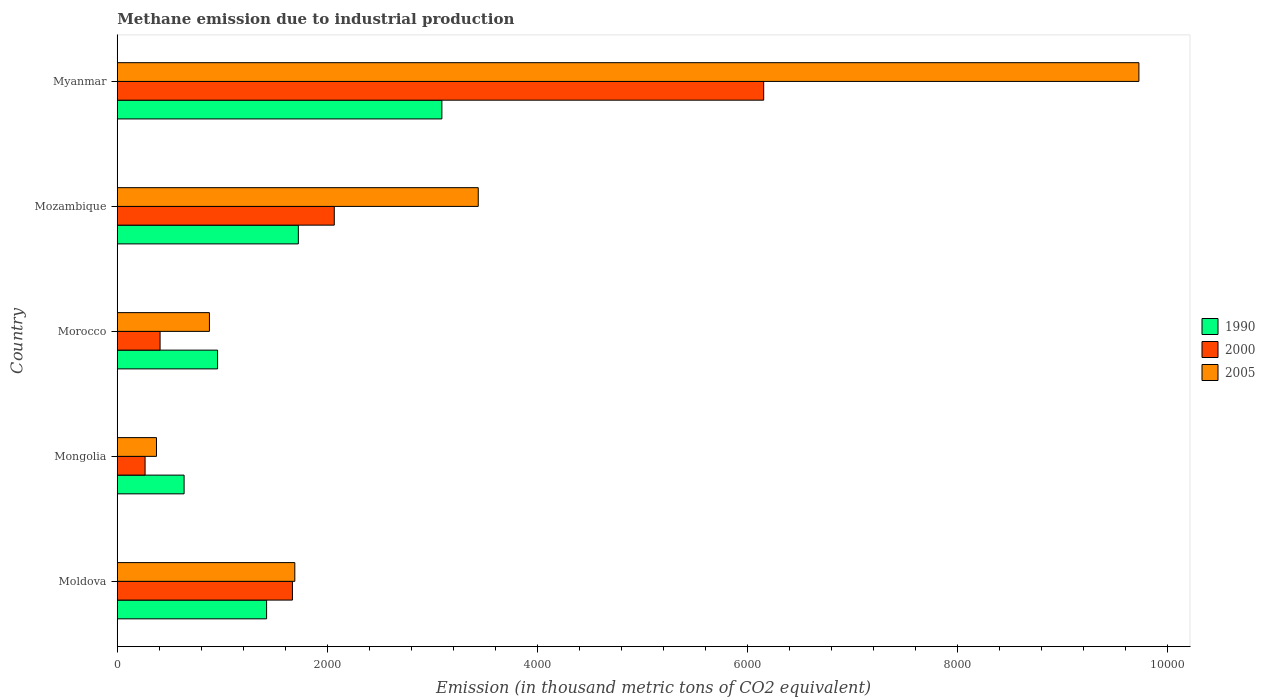How many groups of bars are there?
Provide a succinct answer. 5. Are the number of bars per tick equal to the number of legend labels?
Keep it short and to the point. Yes. Are the number of bars on each tick of the Y-axis equal?
Provide a succinct answer. Yes. How many bars are there on the 2nd tick from the top?
Offer a very short reply. 3. How many bars are there on the 3rd tick from the bottom?
Make the answer very short. 3. What is the label of the 2nd group of bars from the top?
Your answer should be very brief. Mozambique. In how many cases, is the number of bars for a given country not equal to the number of legend labels?
Give a very brief answer. 0. What is the amount of methane emitted in 2005 in Mozambique?
Your answer should be compact. 3438.4. Across all countries, what is the maximum amount of methane emitted in 2000?
Ensure brevity in your answer.  6157.4. Across all countries, what is the minimum amount of methane emitted in 2000?
Your answer should be compact. 264.8. In which country was the amount of methane emitted in 2005 maximum?
Your answer should be compact. Myanmar. In which country was the amount of methane emitted in 1990 minimum?
Make the answer very short. Mongolia. What is the total amount of methane emitted in 2005 in the graph?
Offer a terse response. 1.61e+04. What is the difference between the amount of methane emitted in 1990 in Mongolia and that in Myanmar?
Your response must be concise. -2455.4. What is the difference between the amount of methane emitted in 2000 in Moldova and the amount of methane emitted in 1990 in Myanmar?
Provide a succinct answer. -1423.4. What is the average amount of methane emitted in 2000 per country?
Your answer should be very brief. 2113.08. What is the difference between the amount of methane emitted in 2005 and amount of methane emitted in 2000 in Moldova?
Your response must be concise. 22.6. In how many countries, is the amount of methane emitted in 2005 greater than 2800 thousand metric tons?
Your answer should be very brief. 2. What is the ratio of the amount of methane emitted in 2000 in Morocco to that in Mozambique?
Provide a succinct answer. 0.2. Is the amount of methane emitted in 2000 in Morocco less than that in Myanmar?
Make the answer very short. Yes. Is the difference between the amount of methane emitted in 2005 in Mozambique and Myanmar greater than the difference between the amount of methane emitted in 2000 in Mozambique and Myanmar?
Make the answer very short. No. What is the difference between the highest and the second highest amount of methane emitted in 1990?
Offer a very short reply. 1367.2. What is the difference between the highest and the lowest amount of methane emitted in 2000?
Offer a very short reply. 5892.6. In how many countries, is the amount of methane emitted in 2000 greater than the average amount of methane emitted in 2000 taken over all countries?
Provide a succinct answer. 1. What does the 2nd bar from the top in Mozambique represents?
Offer a very short reply. 2000. Is it the case that in every country, the sum of the amount of methane emitted in 1990 and amount of methane emitted in 2000 is greater than the amount of methane emitted in 2005?
Give a very brief answer. No. How many bars are there?
Keep it short and to the point. 15. Are all the bars in the graph horizontal?
Provide a succinct answer. Yes. How many countries are there in the graph?
Keep it short and to the point. 5. How are the legend labels stacked?
Your response must be concise. Vertical. What is the title of the graph?
Offer a very short reply. Methane emission due to industrial production. Does "2008" appear as one of the legend labels in the graph?
Provide a succinct answer. No. What is the label or title of the X-axis?
Provide a short and direct response. Emission (in thousand metric tons of CO2 equivalent). What is the Emission (in thousand metric tons of CO2 equivalent) of 1990 in Moldova?
Make the answer very short. 1422.3. What is the Emission (in thousand metric tons of CO2 equivalent) of 2000 in Moldova?
Provide a short and direct response. 1668.5. What is the Emission (in thousand metric tons of CO2 equivalent) in 2005 in Moldova?
Offer a very short reply. 1691.1. What is the Emission (in thousand metric tons of CO2 equivalent) in 1990 in Mongolia?
Ensure brevity in your answer.  636.5. What is the Emission (in thousand metric tons of CO2 equivalent) in 2000 in Mongolia?
Ensure brevity in your answer.  264.8. What is the Emission (in thousand metric tons of CO2 equivalent) in 2005 in Mongolia?
Your answer should be compact. 373.5. What is the Emission (in thousand metric tons of CO2 equivalent) of 1990 in Morocco?
Ensure brevity in your answer.  955.4. What is the Emission (in thousand metric tons of CO2 equivalent) of 2000 in Morocco?
Provide a succinct answer. 407.6. What is the Emission (in thousand metric tons of CO2 equivalent) of 2005 in Morocco?
Your answer should be very brief. 877.7. What is the Emission (in thousand metric tons of CO2 equivalent) of 1990 in Mozambique?
Give a very brief answer. 1724.7. What is the Emission (in thousand metric tons of CO2 equivalent) in 2000 in Mozambique?
Provide a succinct answer. 2067.1. What is the Emission (in thousand metric tons of CO2 equivalent) of 2005 in Mozambique?
Offer a very short reply. 3438.4. What is the Emission (in thousand metric tons of CO2 equivalent) in 1990 in Myanmar?
Keep it short and to the point. 3091.9. What is the Emission (in thousand metric tons of CO2 equivalent) in 2000 in Myanmar?
Provide a short and direct response. 6157.4. What is the Emission (in thousand metric tons of CO2 equivalent) in 2005 in Myanmar?
Give a very brief answer. 9731.7. Across all countries, what is the maximum Emission (in thousand metric tons of CO2 equivalent) of 1990?
Keep it short and to the point. 3091.9. Across all countries, what is the maximum Emission (in thousand metric tons of CO2 equivalent) of 2000?
Make the answer very short. 6157.4. Across all countries, what is the maximum Emission (in thousand metric tons of CO2 equivalent) of 2005?
Make the answer very short. 9731.7. Across all countries, what is the minimum Emission (in thousand metric tons of CO2 equivalent) of 1990?
Give a very brief answer. 636.5. Across all countries, what is the minimum Emission (in thousand metric tons of CO2 equivalent) of 2000?
Ensure brevity in your answer.  264.8. Across all countries, what is the minimum Emission (in thousand metric tons of CO2 equivalent) in 2005?
Provide a succinct answer. 373.5. What is the total Emission (in thousand metric tons of CO2 equivalent) in 1990 in the graph?
Give a very brief answer. 7830.8. What is the total Emission (in thousand metric tons of CO2 equivalent) in 2000 in the graph?
Make the answer very short. 1.06e+04. What is the total Emission (in thousand metric tons of CO2 equivalent) in 2005 in the graph?
Offer a very short reply. 1.61e+04. What is the difference between the Emission (in thousand metric tons of CO2 equivalent) in 1990 in Moldova and that in Mongolia?
Provide a short and direct response. 785.8. What is the difference between the Emission (in thousand metric tons of CO2 equivalent) of 2000 in Moldova and that in Mongolia?
Ensure brevity in your answer.  1403.7. What is the difference between the Emission (in thousand metric tons of CO2 equivalent) in 2005 in Moldova and that in Mongolia?
Keep it short and to the point. 1317.6. What is the difference between the Emission (in thousand metric tons of CO2 equivalent) in 1990 in Moldova and that in Morocco?
Your answer should be very brief. 466.9. What is the difference between the Emission (in thousand metric tons of CO2 equivalent) in 2000 in Moldova and that in Morocco?
Keep it short and to the point. 1260.9. What is the difference between the Emission (in thousand metric tons of CO2 equivalent) of 2005 in Moldova and that in Morocco?
Ensure brevity in your answer.  813.4. What is the difference between the Emission (in thousand metric tons of CO2 equivalent) in 1990 in Moldova and that in Mozambique?
Ensure brevity in your answer.  -302.4. What is the difference between the Emission (in thousand metric tons of CO2 equivalent) of 2000 in Moldova and that in Mozambique?
Your answer should be very brief. -398.6. What is the difference between the Emission (in thousand metric tons of CO2 equivalent) in 2005 in Moldova and that in Mozambique?
Provide a short and direct response. -1747.3. What is the difference between the Emission (in thousand metric tons of CO2 equivalent) of 1990 in Moldova and that in Myanmar?
Offer a terse response. -1669.6. What is the difference between the Emission (in thousand metric tons of CO2 equivalent) in 2000 in Moldova and that in Myanmar?
Make the answer very short. -4488.9. What is the difference between the Emission (in thousand metric tons of CO2 equivalent) of 2005 in Moldova and that in Myanmar?
Provide a short and direct response. -8040.6. What is the difference between the Emission (in thousand metric tons of CO2 equivalent) in 1990 in Mongolia and that in Morocco?
Your response must be concise. -318.9. What is the difference between the Emission (in thousand metric tons of CO2 equivalent) of 2000 in Mongolia and that in Morocco?
Your answer should be very brief. -142.8. What is the difference between the Emission (in thousand metric tons of CO2 equivalent) of 2005 in Mongolia and that in Morocco?
Provide a succinct answer. -504.2. What is the difference between the Emission (in thousand metric tons of CO2 equivalent) in 1990 in Mongolia and that in Mozambique?
Your answer should be compact. -1088.2. What is the difference between the Emission (in thousand metric tons of CO2 equivalent) in 2000 in Mongolia and that in Mozambique?
Keep it short and to the point. -1802.3. What is the difference between the Emission (in thousand metric tons of CO2 equivalent) of 2005 in Mongolia and that in Mozambique?
Your response must be concise. -3064.9. What is the difference between the Emission (in thousand metric tons of CO2 equivalent) of 1990 in Mongolia and that in Myanmar?
Make the answer very short. -2455.4. What is the difference between the Emission (in thousand metric tons of CO2 equivalent) of 2000 in Mongolia and that in Myanmar?
Provide a short and direct response. -5892.6. What is the difference between the Emission (in thousand metric tons of CO2 equivalent) of 2005 in Mongolia and that in Myanmar?
Make the answer very short. -9358.2. What is the difference between the Emission (in thousand metric tons of CO2 equivalent) in 1990 in Morocco and that in Mozambique?
Ensure brevity in your answer.  -769.3. What is the difference between the Emission (in thousand metric tons of CO2 equivalent) of 2000 in Morocco and that in Mozambique?
Offer a very short reply. -1659.5. What is the difference between the Emission (in thousand metric tons of CO2 equivalent) in 2005 in Morocco and that in Mozambique?
Make the answer very short. -2560.7. What is the difference between the Emission (in thousand metric tons of CO2 equivalent) in 1990 in Morocco and that in Myanmar?
Offer a terse response. -2136.5. What is the difference between the Emission (in thousand metric tons of CO2 equivalent) in 2000 in Morocco and that in Myanmar?
Keep it short and to the point. -5749.8. What is the difference between the Emission (in thousand metric tons of CO2 equivalent) of 2005 in Morocco and that in Myanmar?
Your answer should be very brief. -8854. What is the difference between the Emission (in thousand metric tons of CO2 equivalent) of 1990 in Mozambique and that in Myanmar?
Offer a very short reply. -1367.2. What is the difference between the Emission (in thousand metric tons of CO2 equivalent) in 2000 in Mozambique and that in Myanmar?
Provide a succinct answer. -4090.3. What is the difference between the Emission (in thousand metric tons of CO2 equivalent) of 2005 in Mozambique and that in Myanmar?
Make the answer very short. -6293.3. What is the difference between the Emission (in thousand metric tons of CO2 equivalent) in 1990 in Moldova and the Emission (in thousand metric tons of CO2 equivalent) in 2000 in Mongolia?
Provide a short and direct response. 1157.5. What is the difference between the Emission (in thousand metric tons of CO2 equivalent) in 1990 in Moldova and the Emission (in thousand metric tons of CO2 equivalent) in 2005 in Mongolia?
Your answer should be compact. 1048.8. What is the difference between the Emission (in thousand metric tons of CO2 equivalent) in 2000 in Moldova and the Emission (in thousand metric tons of CO2 equivalent) in 2005 in Mongolia?
Your response must be concise. 1295. What is the difference between the Emission (in thousand metric tons of CO2 equivalent) in 1990 in Moldova and the Emission (in thousand metric tons of CO2 equivalent) in 2000 in Morocco?
Your answer should be very brief. 1014.7. What is the difference between the Emission (in thousand metric tons of CO2 equivalent) of 1990 in Moldova and the Emission (in thousand metric tons of CO2 equivalent) of 2005 in Morocco?
Your response must be concise. 544.6. What is the difference between the Emission (in thousand metric tons of CO2 equivalent) of 2000 in Moldova and the Emission (in thousand metric tons of CO2 equivalent) of 2005 in Morocco?
Your answer should be very brief. 790.8. What is the difference between the Emission (in thousand metric tons of CO2 equivalent) in 1990 in Moldova and the Emission (in thousand metric tons of CO2 equivalent) in 2000 in Mozambique?
Your answer should be very brief. -644.8. What is the difference between the Emission (in thousand metric tons of CO2 equivalent) of 1990 in Moldova and the Emission (in thousand metric tons of CO2 equivalent) of 2005 in Mozambique?
Your answer should be compact. -2016.1. What is the difference between the Emission (in thousand metric tons of CO2 equivalent) of 2000 in Moldova and the Emission (in thousand metric tons of CO2 equivalent) of 2005 in Mozambique?
Make the answer very short. -1769.9. What is the difference between the Emission (in thousand metric tons of CO2 equivalent) in 1990 in Moldova and the Emission (in thousand metric tons of CO2 equivalent) in 2000 in Myanmar?
Provide a succinct answer. -4735.1. What is the difference between the Emission (in thousand metric tons of CO2 equivalent) in 1990 in Moldova and the Emission (in thousand metric tons of CO2 equivalent) in 2005 in Myanmar?
Your answer should be compact. -8309.4. What is the difference between the Emission (in thousand metric tons of CO2 equivalent) of 2000 in Moldova and the Emission (in thousand metric tons of CO2 equivalent) of 2005 in Myanmar?
Your answer should be compact. -8063.2. What is the difference between the Emission (in thousand metric tons of CO2 equivalent) in 1990 in Mongolia and the Emission (in thousand metric tons of CO2 equivalent) in 2000 in Morocco?
Give a very brief answer. 228.9. What is the difference between the Emission (in thousand metric tons of CO2 equivalent) of 1990 in Mongolia and the Emission (in thousand metric tons of CO2 equivalent) of 2005 in Morocco?
Provide a succinct answer. -241.2. What is the difference between the Emission (in thousand metric tons of CO2 equivalent) of 2000 in Mongolia and the Emission (in thousand metric tons of CO2 equivalent) of 2005 in Morocco?
Your answer should be very brief. -612.9. What is the difference between the Emission (in thousand metric tons of CO2 equivalent) of 1990 in Mongolia and the Emission (in thousand metric tons of CO2 equivalent) of 2000 in Mozambique?
Provide a short and direct response. -1430.6. What is the difference between the Emission (in thousand metric tons of CO2 equivalent) in 1990 in Mongolia and the Emission (in thousand metric tons of CO2 equivalent) in 2005 in Mozambique?
Offer a terse response. -2801.9. What is the difference between the Emission (in thousand metric tons of CO2 equivalent) in 2000 in Mongolia and the Emission (in thousand metric tons of CO2 equivalent) in 2005 in Mozambique?
Provide a short and direct response. -3173.6. What is the difference between the Emission (in thousand metric tons of CO2 equivalent) of 1990 in Mongolia and the Emission (in thousand metric tons of CO2 equivalent) of 2000 in Myanmar?
Offer a terse response. -5520.9. What is the difference between the Emission (in thousand metric tons of CO2 equivalent) in 1990 in Mongolia and the Emission (in thousand metric tons of CO2 equivalent) in 2005 in Myanmar?
Offer a terse response. -9095.2. What is the difference between the Emission (in thousand metric tons of CO2 equivalent) in 2000 in Mongolia and the Emission (in thousand metric tons of CO2 equivalent) in 2005 in Myanmar?
Provide a succinct answer. -9466.9. What is the difference between the Emission (in thousand metric tons of CO2 equivalent) of 1990 in Morocco and the Emission (in thousand metric tons of CO2 equivalent) of 2000 in Mozambique?
Keep it short and to the point. -1111.7. What is the difference between the Emission (in thousand metric tons of CO2 equivalent) in 1990 in Morocco and the Emission (in thousand metric tons of CO2 equivalent) in 2005 in Mozambique?
Give a very brief answer. -2483. What is the difference between the Emission (in thousand metric tons of CO2 equivalent) of 2000 in Morocco and the Emission (in thousand metric tons of CO2 equivalent) of 2005 in Mozambique?
Offer a terse response. -3030.8. What is the difference between the Emission (in thousand metric tons of CO2 equivalent) of 1990 in Morocco and the Emission (in thousand metric tons of CO2 equivalent) of 2000 in Myanmar?
Ensure brevity in your answer.  -5202. What is the difference between the Emission (in thousand metric tons of CO2 equivalent) in 1990 in Morocco and the Emission (in thousand metric tons of CO2 equivalent) in 2005 in Myanmar?
Offer a terse response. -8776.3. What is the difference between the Emission (in thousand metric tons of CO2 equivalent) in 2000 in Morocco and the Emission (in thousand metric tons of CO2 equivalent) in 2005 in Myanmar?
Provide a short and direct response. -9324.1. What is the difference between the Emission (in thousand metric tons of CO2 equivalent) in 1990 in Mozambique and the Emission (in thousand metric tons of CO2 equivalent) in 2000 in Myanmar?
Offer a terse response. -4432.7. What is the difference between the Emission (in thousand metric tons of CO2 equivalent) of 1990 in Mozambique and the Emission (in thousand metric tons of CO2 equivalent) of 2005 in Myanmar?
Your answer should be very brief. -8007. What is the difference between the Emission (in thousand metric tons of CO2 equivalent) of 2000 in Mozambique and the Emission (in thousand metric tons of CO2 equivalent) of 2005 in Myanmar?
Offer a very short reply. -7664.6. What is the average Emission (in thousand metric tons of CO2 equivalent) of 1990 per country?
Keep it short and to the point. 1566.16. What is the average Emission (in thousand metric tons of CO2 equivalent) of 2000 per country?
Your answer should be very brief. 2113.08. What is the average Emission (in thousand metric tons of CO2 equivalent) in 2005 per country?
Provide a short and direct response. 3222.48. What is the difference between the Emission (in thousand metric tons of CO2 equivalent) in 1990 and Emission (in thousand metric tons of CO2 equivalent) in 2000 in Moldova?
Ensure brevity in your answer.  -246.2. What is the difference between the Emission (in thousand metric tons of CO2 equivalent) of 1990 and Emission (in thousand metric tons of CO2 equivalent) of 2005 in Moldova?
Your answer should be very brief. -268.8. What is the difference between the Emission (in thousand metric tons of CO2 equivalent) of 2000 and Emission (in thousand metric tons of CO2 equivalent) of 2005 in Moldova?
Keep it short and to the point. -22.6. What is the difference between the Emission (in thousand metric tons of CO2 equivalent) of 1990 and Emission (in thousand metric tons of CO2 equivalent) of 2000 in Mongolia?
Provide a succinct answer. 371.7. What is the difference between the Emission (in thousand metric tons of CO2 equivalent) of 1990 and Emission (in thousand metric tons of CO2 equivalent) of 2005 in Mongolia?
Keep it short and to the point. 263. What is the difference between the Emission (in thousand metric tons of CO2 equivalent) of 2000 and Emission (in thousand metric tons of CO2 equivalent) of 2005 in Mongolia?
Give a very brief answer. -108.7. What is the difference between the Emission (in thousand metric tons of CO2 equivalent) of 1990 and Emission (in thousand metric tons of CO2 equivalent) of 2000 in Morocco?
Offer a very short reply. 547.8. What is the difference between the Emission (in thousand metric tons of CO2 equivalent) in 1990 and Emission (in thousand metric tons of CO2 equivalent) in 2005 in Morocco?
Ensure brevity in your answer.  77.7. What is the difference between the Emission (in thousand metric tons of CO2 equivalent) in 2000 and Emission (in thousand metric tons of CO2 equivalent) in 2005 in Morocco?
Offer a terse response. -470.1. What is the difference between the Emission (in thousand metric tons of CO2 equivalent) of 1990 and Emission (in thousand metric tons of CO2 equivalent) of 2000 in Mozambique?
Give a very brief answer. -342.4. What is the difference between the Emission (in thousand metric tons of CO2 equivalent) of 1990 and Emission (in thousand metric tons of CO2 equivalent) of 2005 in Mozambique?
Keep it short and to the point. -1713.7. What is the difference between the Emission (in thousand metric tons of CO2 equivalent) in 2000 and Emission (in thousand metric tons of CO2 equivalent) in 2005 in Mozambique?
Your response must be concise. -1371.3. What is the difference between the Emission (in thousand metric tons of CO2 equivalent) in 1990 and Emission (in thousand metric tons of CO2 equivalent) in 2000 in Myanmar?
Provide a succinct answer. -3065.5. What is the difference between the Emission (in thousand metric tons of CO2 equivalent) of 1990 and Emission (in thousand metric tons of CO2 equivalent) of 2005 in Myanmar?
Offer a terse response. -6639.8. What is the difference between the Emission (in thousand metric tons of CO2 equivalent) of 2000 and Emission (in thousand metric tons of CO2 equivalent) of 2005 in Myanmar?
Give a very brief answer. -3574.3. What is the ratio of the Emission (in thousand metric tons of CO2 equivalent) of 1990 in Moldova to that in Mongolia?
Offer a very short reply. 2.23. What is the ratio of the Emission (in thousand metric tons of CO2 equivalent) of 2000 in Moldova to that in Mongolia?
Your answer should be compact. 6.3. What is the ratio of the Emission (in thousand metric tons of CO2 equivalent) in 2005 in Moldova to that in Mongolia?
Your answer should be very brief. 4.53. What is the ratio of the Emission (in thousand metric tons of CO2 equivalent) of 1990 in Moldova to that in Morocco?
Give a very brief answer. 1.49. What is the ratio of the Emission (in thousand metric tons of CO2 equivalent) in 2000 in Moldova to that in Morocco?
Your answer should be very brief. 4.09. What is the ratio of the Emission (in thousand metric tons of CO2 equivalent) in 2005 in Moldova to that in Morocco?
Your answer should be very brief. 1.93. What is the ratio of the Emission (in thousand metric tons of CO2 equivalent) of 1990 in Moldova to that in Mozambique?
Your answer should be compact. 0.82. What is the ratio of the Emission (in thousand metric tons of CO2 equivalent) of 2000 in Moldova to that in Mozambique?
Offer a terse response. 0.81. What is the ratio of the Emission (in thousand metric tons of CO2 equivalent) in 2005 in Moldova to that in Mozambique?
Your response must be concise. 0.49. What is the ratio of the Emission (in thousand metric tons of CO2 equivalent) in 1990 in Moldova to that in Myanmar?
Make the answer very short. 0.46. What is the ratio of the Emission (in thousand metric tons of CO2 equivalent) of 2000 in Moldova to that in Myanmar?
Make the answer very short. 0.27. What is the ratio of the Emission (in thousand metric tons of CO2 equivalent) in 2005 in Moldova to that in Myanmar?
Offer a terse response. 0.17. What is the ratio of the Emission (in thousand metric tons of CO2 equivalent) of 1990 in Mongolia to that in Morocco?
Offer a terse response. 0.67. What is the ratio of the Emission (in thousand metric tons of CO2 equivalent) of 2000 in Mongolia to that in Morocco?
Keep it short and to the point. 0.65. What is the ratio of the Emission (in thousand metric tons of CO2 equivalent) of 2005 in Mongolia to that in Morocco?
Your answer should be compact. 0.43. What is the ratio of the Emission (in thousand metric tons of CO2 equivalent) in 1990 in Mongolia to that in Mozambique?
Provide a short and direct response. 0.37. What is the ratio of the Emission (in thousand metric tons of CO2 equivalent) in 2000 in Mongolia to that in Mozambique?
Keep it short and to the point. 0.13. What is the ratio of the Emission (in thousand metric tons of CO2 equivalent) of 2005 in Mongolia to that in Mozambique?
Offer a terse response. 0.11. What is the ratio of the Emission (in thousand metric tons of CO2 equivalent) of 1990 in Mongolia to that in Myanmar?
Give a very brief answer. 0.21. What is the ratio of the Emission (in thousand metric tons of CO2 equivalent) in 2000 in Mongolia to that in Myanmar?
Offer a terse response. 0.04. What is the ratio of the Emission (in thousand metric tons of CO2 equivalent) in 2005 in Mongolia to that in Myanmar?
Offer a terse response. 0.04. What is the ratio of the Emission (in thousand metric tons of CO2 equivalent) in 1990 in Morocco to that in Mozambique?
Offer a very short reply. 0.55. What is the ratio of the Emission (in thousand metric tons of CO2 equivalent) of 2000 in Morocco to that in Mozambique?
Provide a short and direct response. 0.2. What is the ratio of the Emission (in thousand metric tons of CO2 equivalent) in 2005 in Morocco to that in Mozambique?
Keep it short and to the point. 0.26. What is the ratio of the Emission (in thousand metric tons of CO2 equivalent) in 1990 in Morocco to that in Myanmar?
Your answer should be compact. 0.31. What is the ratio of the Emission (in thousand metric tons of CO2 equivalent) of 2000 in Morocco to that in Myanmar?
Offer a terse response. 0.07. What is the ratio of the Emission (in thousand metric tons of CO2 equivalent) of 2005 in Morocco to that in Myanmar?
Offer a terse response. 0.09. What is the ratio of the Emission (in thousand metric tons of CO2 equivalent) in 1990 in Mozambique to that in Myanmar?
Your answer should be very brief. 0.56. What is the ratio of the Emission (in thousand metric tons of CO2 equivalent) in 2000 in Mozambique to that in Myanmar?
Ensure brevity in your answer.  0.34. What is the ratio of the Emission (in thousand metric tons of CO2 equivalent) of 2005 in Mozambique to that in Myanmar?
Offer a very short reply. 0.35. What is the difference between the highest and the second highest Emission (in thousand metric tons of CO2 equivalent) in 1990?
Give a very brief answer. 1367.2. What is the difference between the highest and the second highest Emission (in thousand metric tons of CO2 equivalent) of 2000?
Ensure brevity in your answer.  4090.3. What is the difference between the highest and the second highest Emission (in thousand metric tons of CO2 equivalent) of 2005?
Your answer should be very brief. 6293.3. What is the difference between the highest and the lowest Emission (in thousand metric tons of CO2 equivalent) of 1990?
Offer a terse response. 2455.4. What is the difference between the highest and the lowest Emission (in thousand metric tons of CO2 equivalent) in 2000?
Your response must be concise. 5892.6. What is the difference between the highest and the lowest Emission (in thousand metric tons of CO2 equivalent) of 2005?
Keep it short and to the point. 9358.2. 